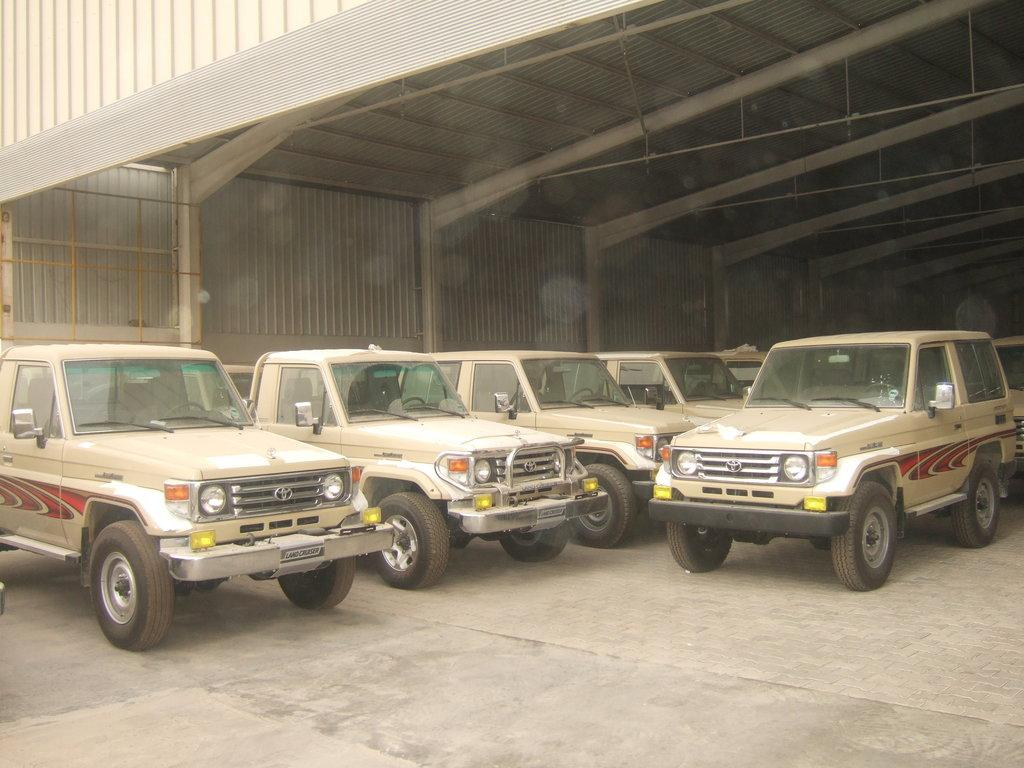What can be seen in the image? There are vehicles in the image. Where are the vehicles located? The vehicles are parked in a shed. What is visible at the top of the image? There is a roof visible at the top of the image. How many trucks are paying attention to the cent in the image? There are no trucks or cents present in the image. 